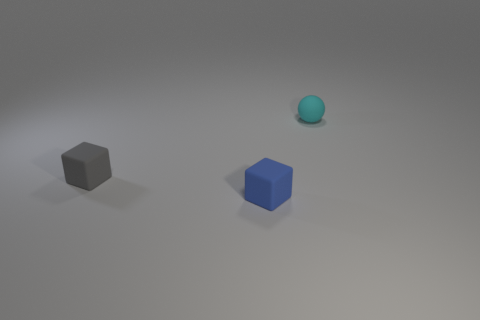What number of objects are either cyan matte balls or small blue things?
Your answer should be compact. 2. How many small rubber things are both in front of the small cyan thing and behind the small gray thing?
Provide a short and direct response. 0. Is the number of cyan matte spheres that are left of the blue cube less than the number of tiny brown cubes?
Your answer should be very brief. No. What is the shape of the gray rubber object that is the same size as the blue cube?
Make the answer very short. Cube. Is the cyan ball the same size as the gray rubber thing?
Offer a terse response. Yes. What number of objects are either small blue shiny balls or small matte things that are left of the blue rubber object?
Provide a short and direct response. 1. Are there fewer tiny gray matte cubes that are left of the blue rubber cube than tiny balls in front of the small gray block?
Your answer should be very brief. No. How many other things are there of the same material as the gray block?
Keep it short and to the point. 2. There is a small rubber block that is behind the tiny blue cube; is its color the same as the ball?
Offer a terse response. No. Are there any tiny gray things that are behind the tiny matte ball on the right side of the gray matte thing?
Provide a short and direct response. No. 